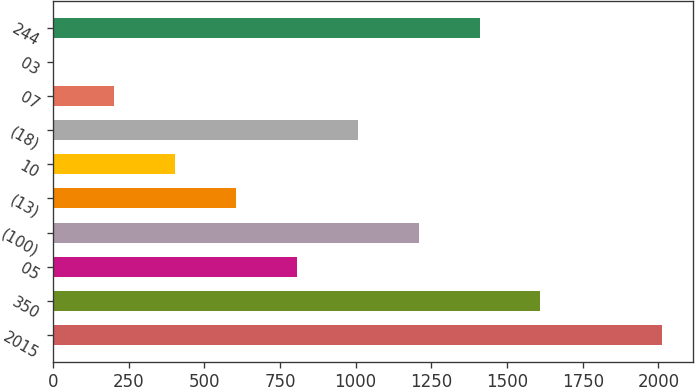Convert chart to OTSL. <chart><loc_0><loc_0><loc_500><loc_500><bar_chart><fcel>2015<fcel>350<fcel>05<fcel>(100)<fcel>(13)<fcel>10<fcel>(18)<fcel>07<fcel>03<fcel>244<nl><fcel>2013<fcel>1610.46<fcel>805.38<fcel>1207.92<fcel>604.11<fcel>402.84<fcel>1006.65<fcel>201.57<fcel>0.3<fcel>1409.19<nl></chart> 